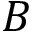<formula> <loc_0><loc_0><loc_500><loc_500>B</formula> 